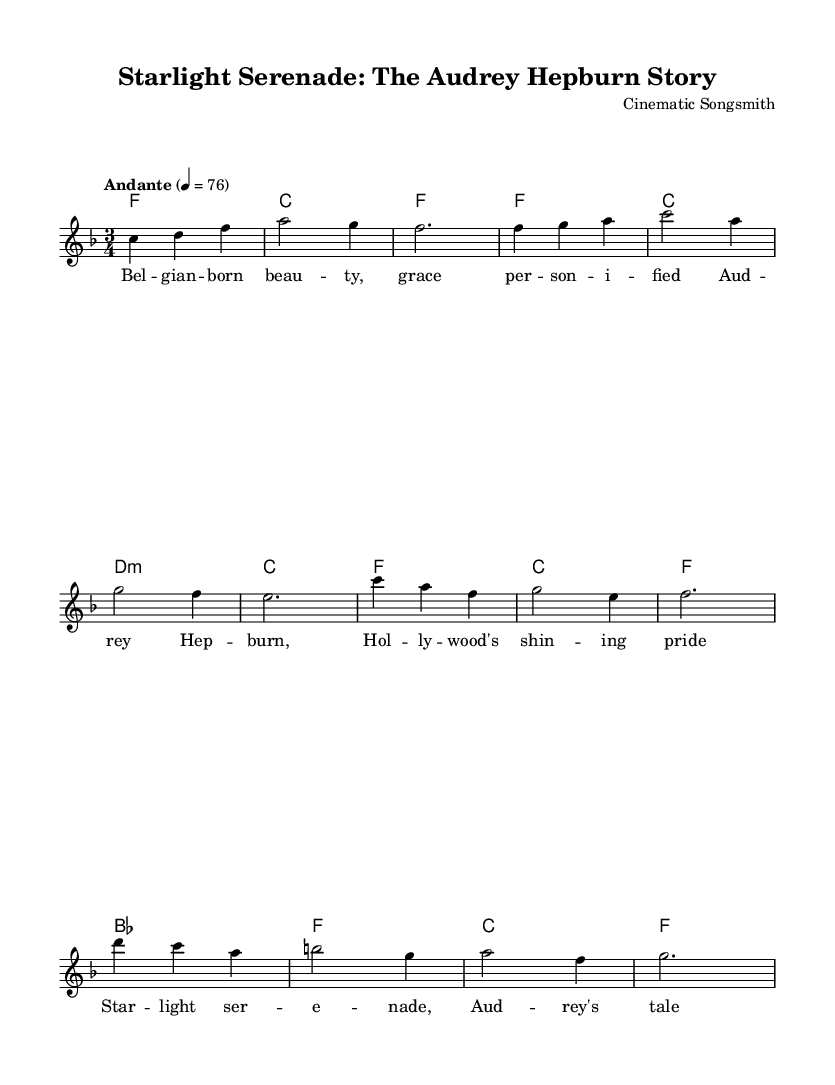What is the key signature of this music? The key signature is F major, which has one flat (B flat).
Answer: F major What is the time signature of this piece? The time signature is 3/4, indicating three beats per measure with a quarter note receiving one beat.
Answer: 3/4 What is the tempo marking for this music? The tempo marking is Andante, which indicates a moderately slow tempo, typically around 76 beats per minute.
Answer: Andante How many sections are in the structure of this song? The song structure includes an Intro, Verse, Chorus, and Bridge, making a total of four distinct sections.
Answer: Four What is the starting note of the melody? The starting note of the melody is C, which is indicated at the beginning of the piece.
Answer: C How many measures are in the Verse section? The Verse section contains four measures, as seen in the notation.
Answer: Four What lyric is repeated in the chorus? The lyric "Audrey's tale unfolds" is featured in the chorus, emphasizing the storytelling nature of the song.
Answer: Audrey's tale unfolds 